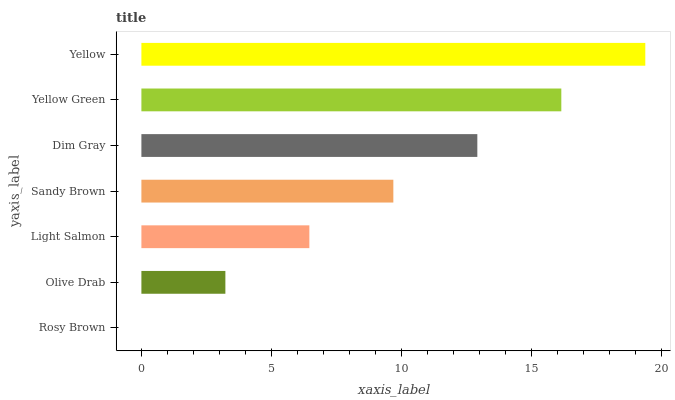Is Rosy Brown the minimum?
Answer yes or no. Yes. Is Yellow the maximum?
Answer yes or no. Yes. Is Olive Drab the minimum?
Answer yes or no. No. Is Olive Drab the maximum?
Answer yes or no. No. Is Olive Drab greater than Rosy Brown?
Answer yes or no. Yes. Is Rosy Brown less than Olive Drab?
Answer yes or no. Yes. Is Rosy Brown greater than Olive Drab?
Answer yes or no. No. Is Olive Drab less than Rosy Brown?
Answer yes or no. No. Is Sandy Brown the high median?
Answer yes or no. Yes. Is Sandy Brown the low median?
Answer yes or no. Yes. Is Yellow Green the high median?
Answer yes or no. No. Is Rosy Brown the low median?
Answer yes or no. No. 